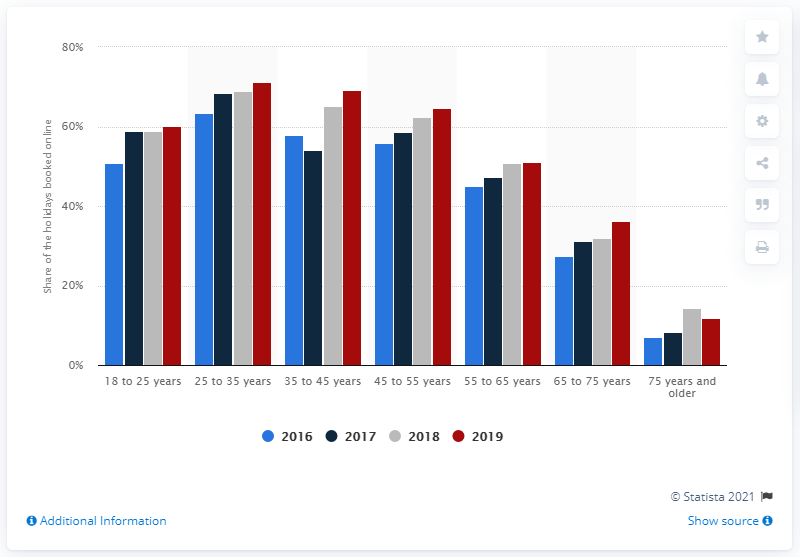Highlight a few significant elements in this photo. Travix's revenue in 2017 was 71.1 million. In 2017, TUI Netherlands, KLM, and Travix were the top three online travel agencies in the Netherlands, as they formed a powerful alliance in that year. In 2019, 71.1% of 25-35 year olds booked their holidays online. 